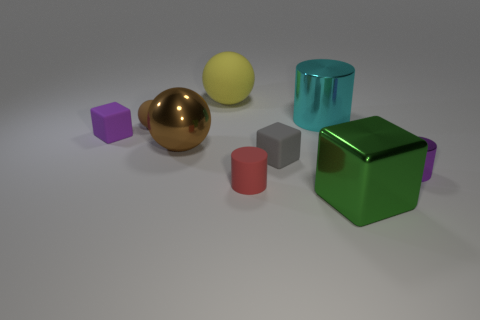There is a shiny thing that is the same color as the tiny sphere; what size is it?
Keep it short and to the point. Large. There is a tiny sphere; does it have the same color as the large ball that is in front of the large rubber ball?
Give a very brief answer. Yes. There is another small object that is the same color as the tiny shiny thing; what material is it?
Make the answer very short. Rubber. What is the color of the cylinder that is the same material as the small gray object?
Provide a succinct answer. Red. What number of large objects are either brown matte objects or red cylinders?
Make the answer very short. 0. Are there fewer red things than shiny objects?
Offer a terse response. Yes. The other big metal thing that is the same shape as the purple metallic object is what color?
Give a very brief answer. Cyan. Are there more brown objects than large brown metal objects?
Your answer should be very brief. Yes. What number of other objects are there of the same material as the large cyan cylinder?
Keep it short and to the point. 3. There is a tiny purple thing that is right of the tiny purple thing left of the ball behind the small brown matte sphere; what is its shape?
Make the answer very short. Cylinder. 